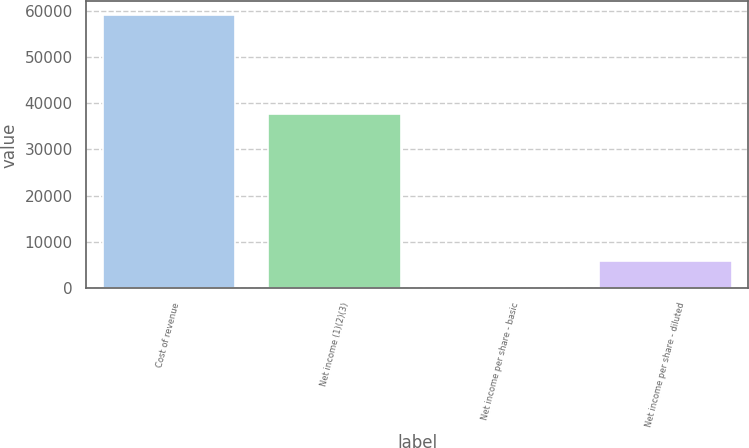Convert chart. <chart><loc_0><loc_0><loc_500><loc_500><bar_chart><fcel>Cost of revenue<fcel>Net income (1)(2)(3)<fcel>Net income per share - basic<fcel>Net income per share - diluted<nl><fcel>59031<fcel>37705<fcel>0.13<fcel>5903.22<nl></chart> 